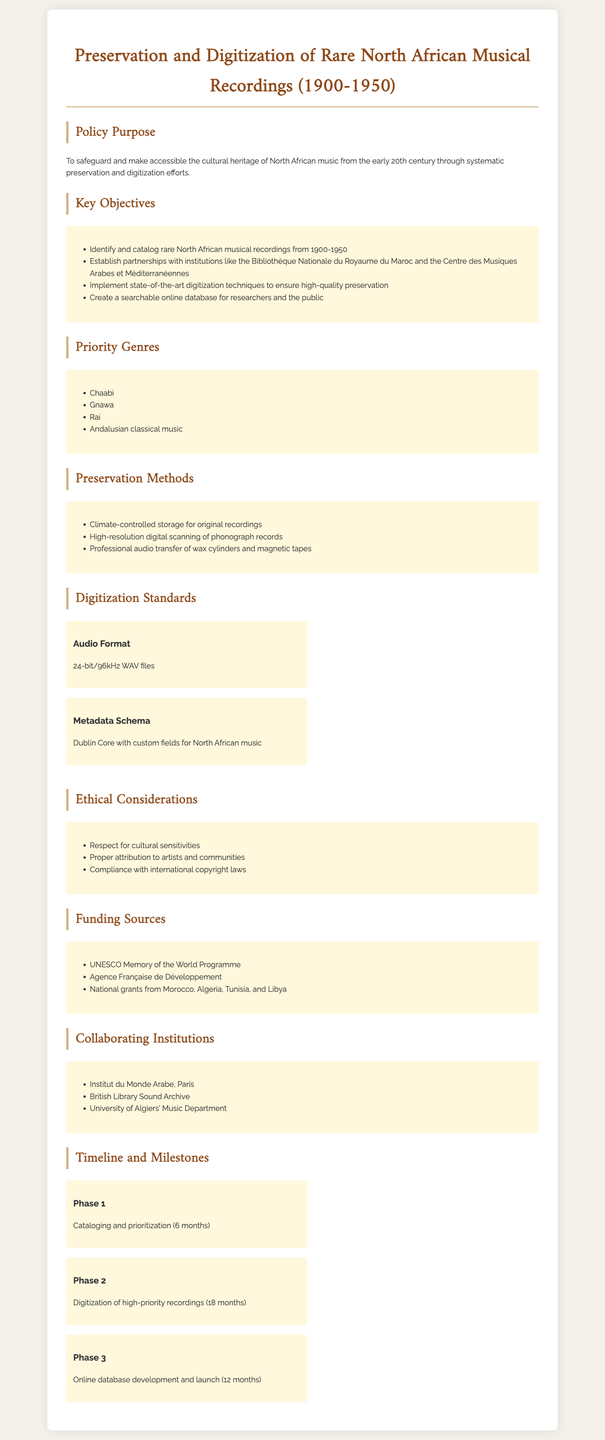What is the purpose of the policy? The purpose of the policy is to safeguard and make accessible the cultural heritage of North African music from the early 20th century through systematic preservation and digitization efforts.
Answer: To safeguard and make accessible the cultural heritage of North African music from the early 20th century through systematic preservation and digitization efforts Which institutions are involved in collaboration? The document lists specific institutions collaborating on the project.
Answer: Institut du Monde Arabe, Paris; British Library Sound Archive; University of Algiers' Music Department What is the audio format standard for digitization? The audio format specified for digitization is mentioned in the digitization standards section.
Answer: 24-bit/96kHz WAV files How many phases are outlined in the timeline? The document mentions phases for the project in the timeline section.
Answer: 3 phases List one of the priority genres for preservation. The document specifies genres that are prioritized in the preservation policy section.
Answer: Chaabi What is one ethical consideration mentioned in the document? The document outlines ethical considerations that guide the preservation and digitization efforts.
Answer: Respect for cultural sensitivities What is the estimated duration for Phase 1? The timeline indicates how long each phase will take, particularly the first phase.
Answer: 6 months What is the funding source mentioned? The document provides examples of sources of funding for the project.
Answer: UNESCO Memory of the World Programme 